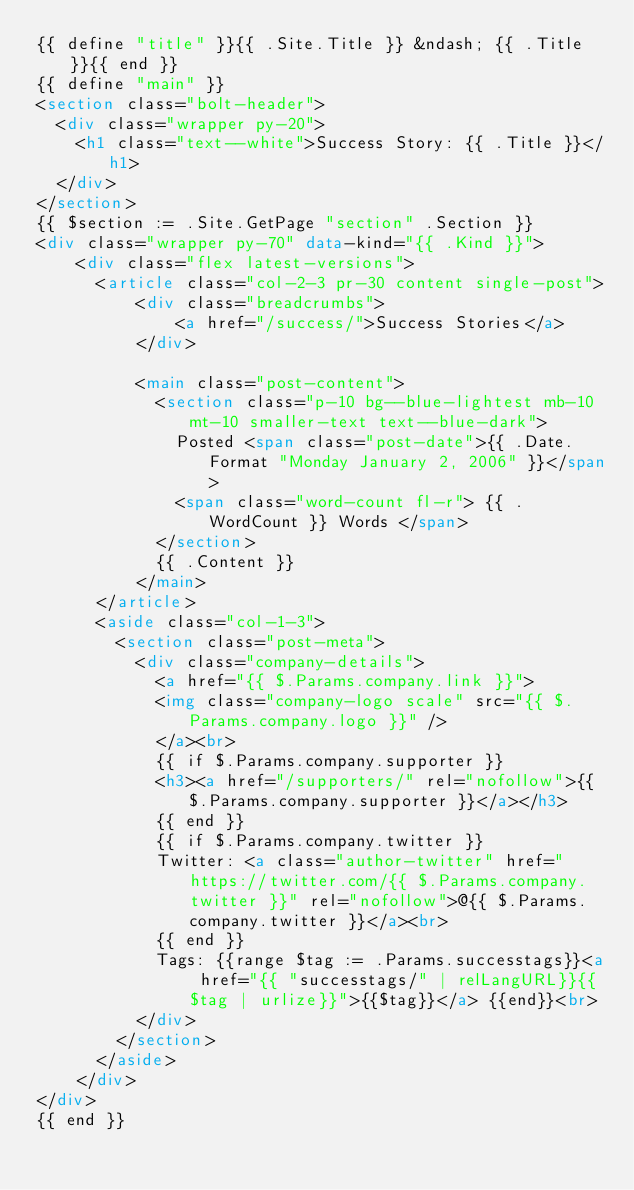Convert code to text. <code><loc_0><loc_0><loc_500><loc_500><_HTML_>{{ define "title" }}{{ .Site.Title }} &ndash; {{ .Title }}{{ end }}
{{ define "main" }}
<section class="bolt-header">
  <div class="wrapper py-20">
    <h1 class="text--white">Success Story: {{ .Title }}</h1>
  </div>
</section>
{{ $section := .Site.GetPage "section" .Section }}
<div class="wrapper py-70" data-kind="{{ .Kind }}">
    <div class="flex latest-versions">
      <article class="col-2-3 pr-30 content single-post">
          <div class="breadcrumbs">
              <a href="/success/">Success Stories</a>
          </div>

          <main class="post-content">
            <section class="p-10 bg--blue-lightest mb-10 mt-10 smaller-text text--blue-dark">
              Posted <span class="post-date">{{ .Date.Format "Monday January 2, 2006" }}</span>
              <span class="word-count fl-r"> {{ .WordCount }} Words </span>
            </section>
            {{ .Content }}
          </main>
      </article>
      <aside class="col-1-3">
        <section class="post-meta">
          <div class="company-details">
            <a href="{{ $.Params.company.link }}">
            <img class="company-logo scale" src="{{ $.Params.company.logo }}" />
            </a><br>
            {{ if $.Params.company.supporter }}
            <h3><a href="/supporters/" rel="nofollow">{{ $.Params.company.supporter }}</a></h3>
            {{ end }}
            {{ if $.Params.company.twitter }}
            Twitter: <a class="author-twitter" href="https://twitter.com/{{ $.Params.company.twitter }}" rel="nofollow">@{{ $.Params.company.twitter }}</a><br>
            {{ end }}
            Tags: {{range $tag := .Params.successtags}}<a href="{{ "successtags/" | relLangURL}}{{$tag | urlize}}">{{$tag}}</a> {{end}}<br>
          </div>
        </section>
      </aside>
    </div>
</div>
{{ end }}

</code> 